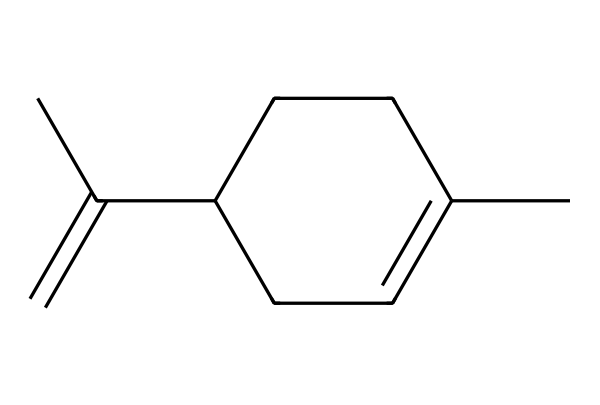What is the main functional group present in limonene? The structure shows that limonene contains a double bond between carbon atoms (C=C), which classifies it as an alkene.
Answer: alkene How many carbon atoms are in limonene? By analyzing the SMILES representation, it states there are 10 carbon atoms connected in various configurations forming a cyclic and acyclic structure.
Answer: 10 What is the molecular formula of limonene? Counting the carbon and hydrogen atoms from the structure, the molecular formula is derived as C10H16.
Answer: C10H16 Is limonene a saturated or unsaturated compound? The presence of a double bond (C=C) indicates that limonene is not fully saturated with hydrogen atoms. Therefore, it is classified as unsaturated.
Answer: unsaturated Which type of terpene is limonene classified as? Limonene has a cyclic structure with the notable presence of a double bond, classifying it as a monoterpene.
Answer: monoterpene What natural sources commonly contain limonene? Limonene is predominantly found in citrus fruits such as oranges, lemons, and limes due to their essential oils.
Answer: citrus fruits 